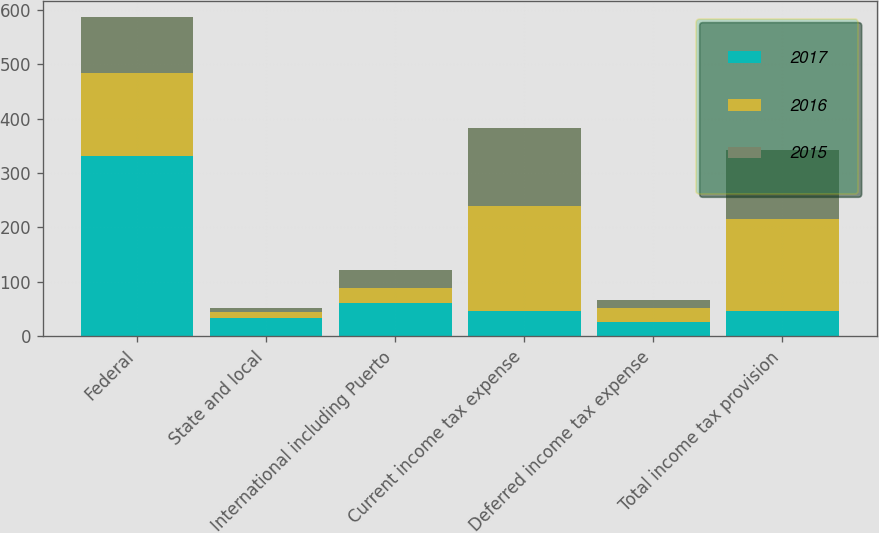<chart> <loc_0><loc_0><loc_500><loc_500><stacked_bar_chart><ecel><fcel>Federal<fcel>State and local<fcel>International including Puerto<fcel>Current income tax expense<fcel>Deferred income tax expense<fcel>Total income tax provision<nl><fcel>2017<fcel>330.8<fcel>32.8<fcel>60.6<fcel>47.05<fcel>27.1<fcel>47.05<nl><fcel>2016<fcel>153.4<fcel>12.1<fcel>27.4<fcel>192.9<fcel>24.5<fcel>168.4<nl><fcel>2015<fcel>102.4<fcel>7.4<fcel>33.5<fcel>143.3<fcel>15.8<fcel>127.5<nl></chart> 